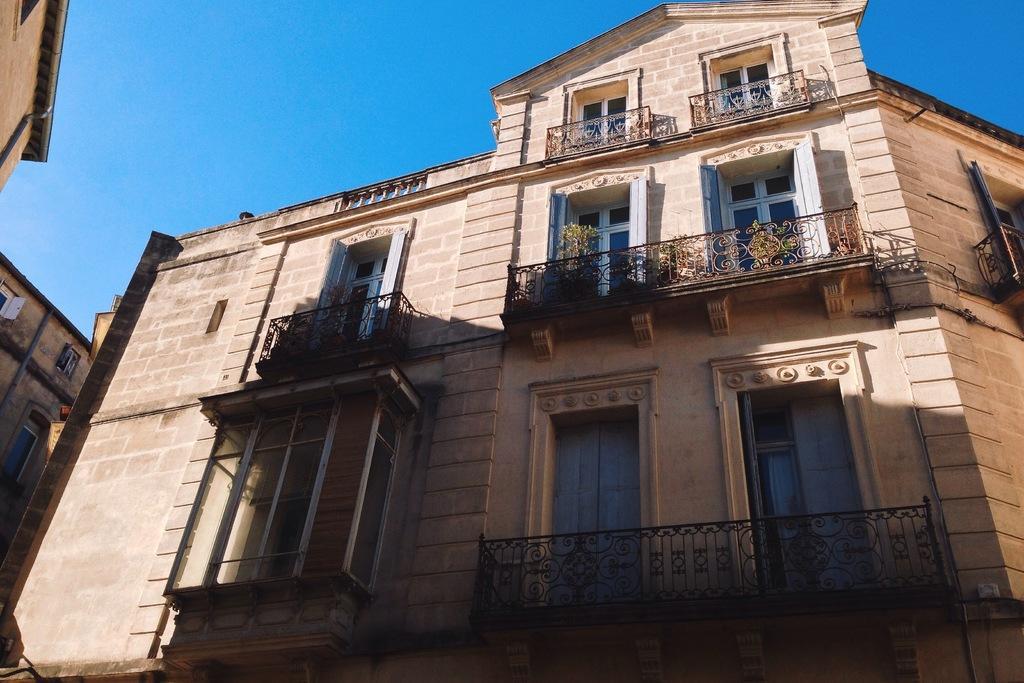Could you give a brief overview of what you see in this image? In this image I can see number of buildings, windows, few plants, shadows and sky. 